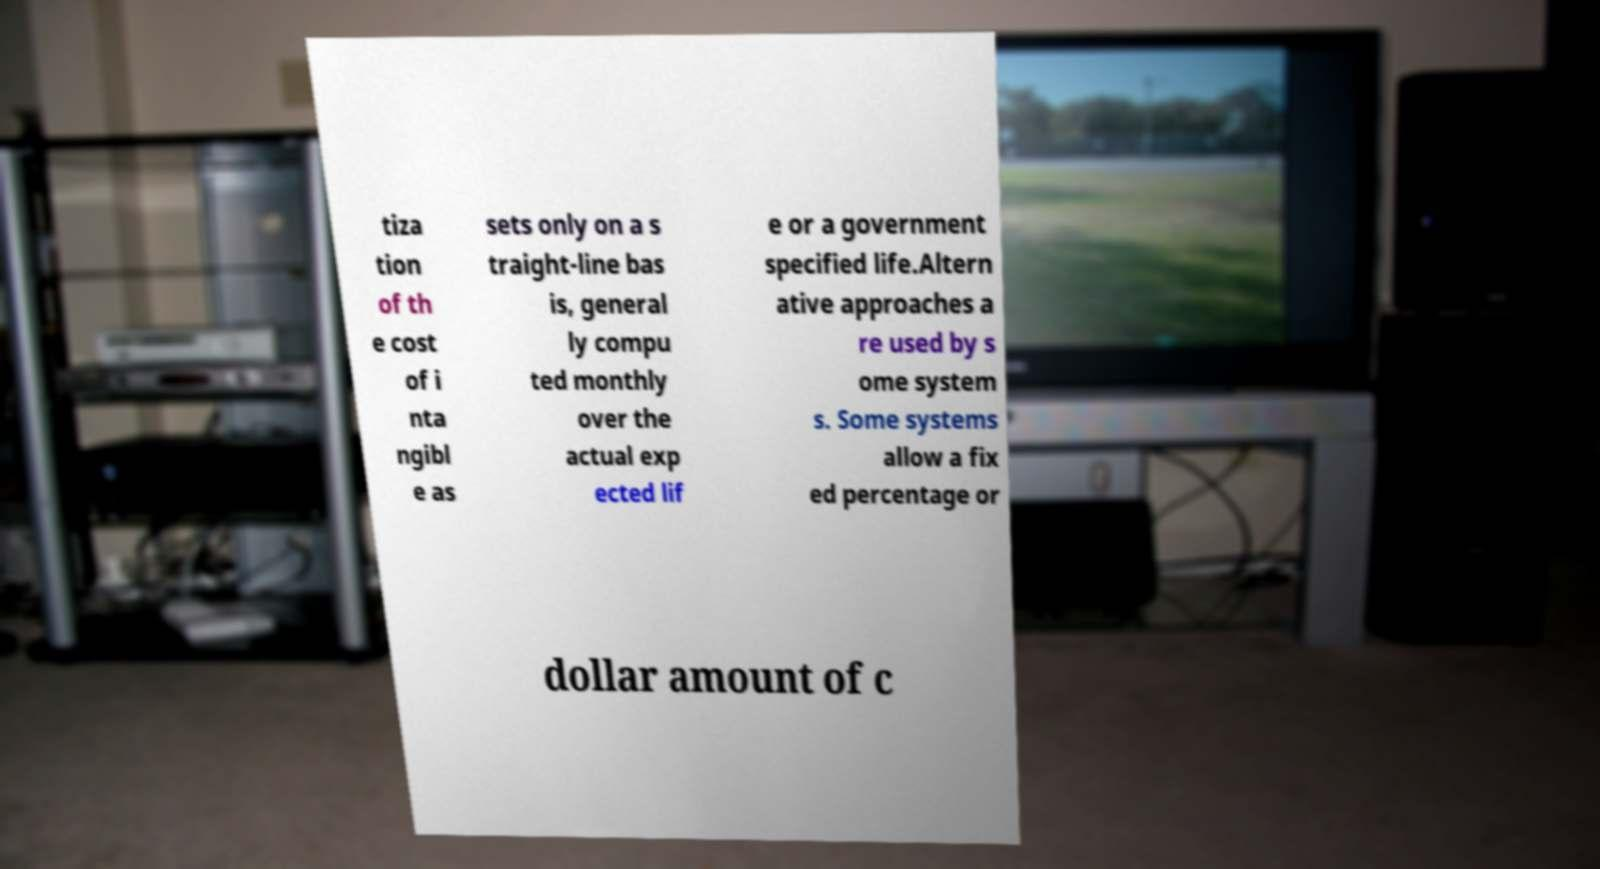Please identify and transcribe the text found in this image. tiza tion of th e cost of i nta ngibl e as sets only on a s traight-line bas is, general ly compu ted monthly over the actual exp ected lif e or a government specified life.Altern ative approaches a re used by s ome system s. Some systems allow a fix ed percentage or dollar amount of c 